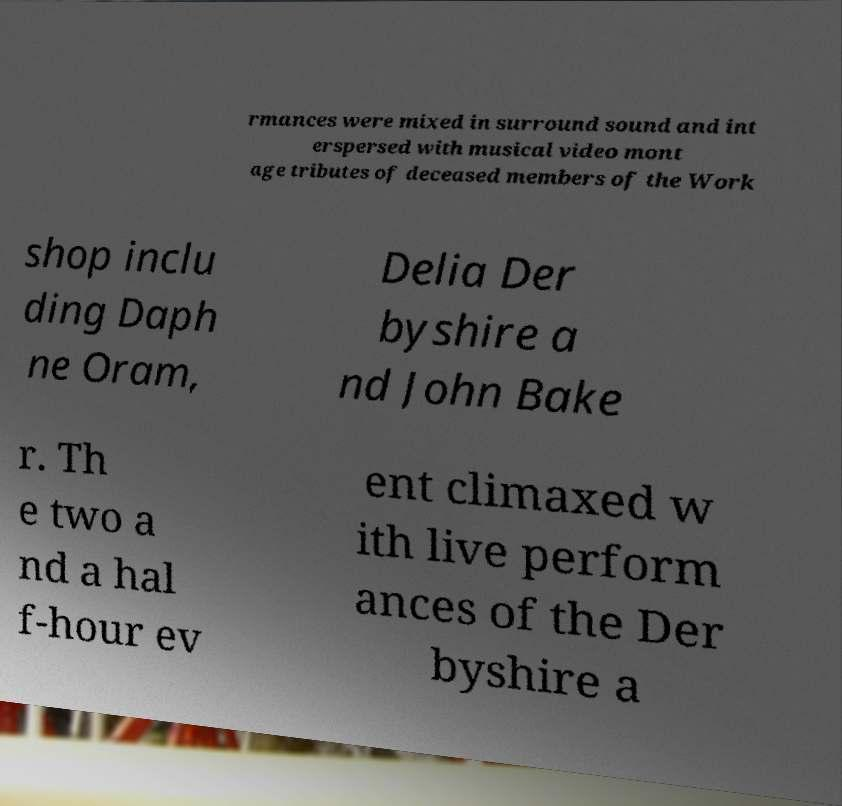Could you extract and type out the text from this image? rmances were mixed in surround sound and int erspersed with musical video mont age tributes of deceased members of the Work shop inclu ding Daph ne Oram, Delia Der byshire a nd John Bake r. Th e two a nd a hal f-hour ev ent climaxed w ith live perform ances of the Der byshire a 